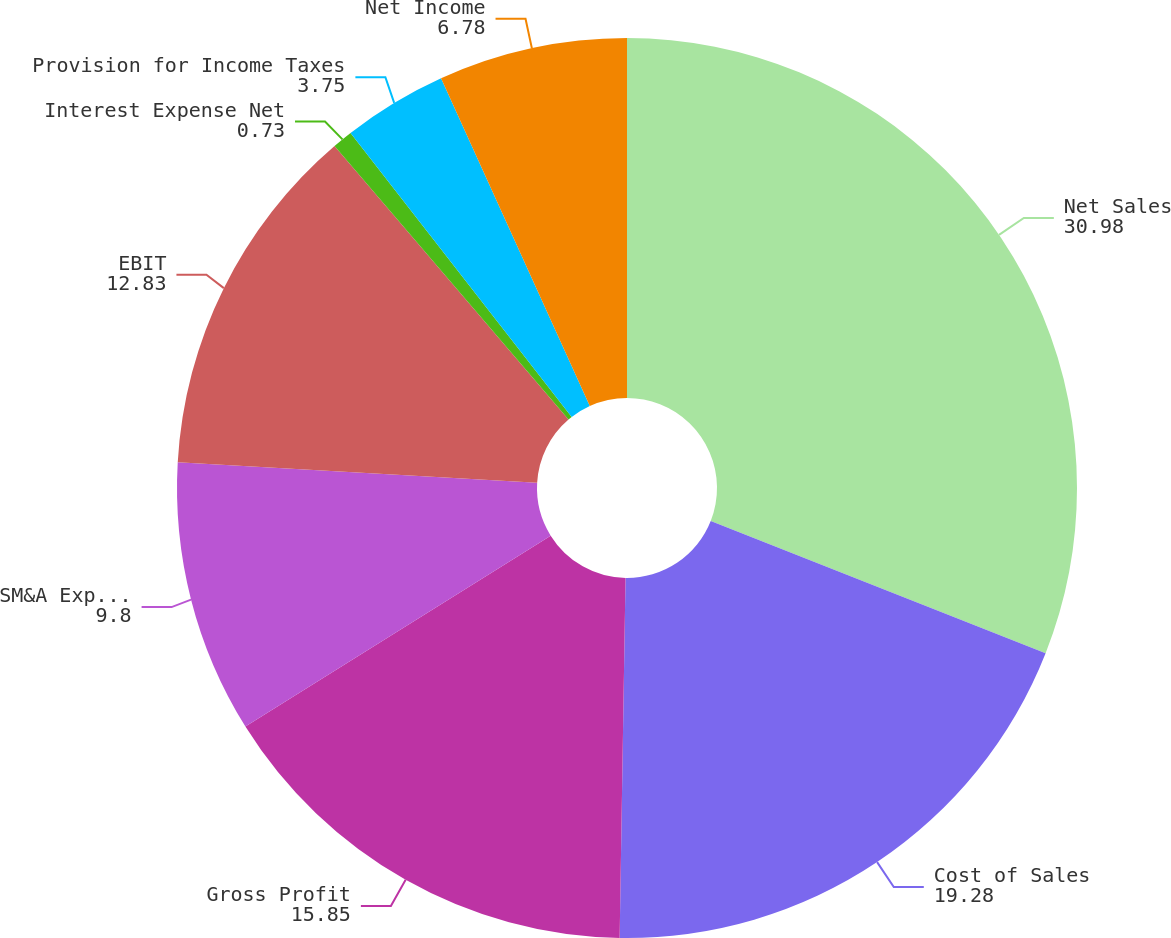Convert chart. <chart><loc_0><loc_0><loc_500><loc_500><pie_chart><fcel>Net Sales<fcel>Cost of Sales<fcel>Gross Profit<fcel>SM&A Expense<fcel>EBIT<fcel>Interest Expense Net<fcel>Provision for Income Taxes<fcel>Net Income<nl><fcel>30.98%<fcel>19.28%<fcel>15.85%<fcel>9.8%<fcel>12.83%<fcel>0.73%<fcel>3.75%<fcel>6.78%<nl></chart> 